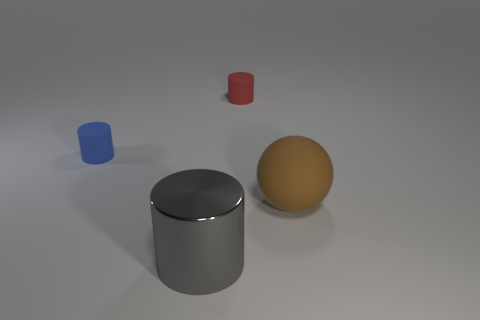Subtract all tiny rubber cylinders. How many cylinders are left? 1 Add 4 red things. How many objects exist? 8 Subtract all red cylinders. How many cylinders are left? 2 Subtract all spheres. How many objects are left? 3 Add 1 big matte things. How many big matte things are left? 2 Add 4 shiny cylinders. How many shiny cylinders exist? 5 Subtract 0 red balls. How many objects are left? 4 Subtract 1 cylinders. How many cylinders are left? 2 Subtract all gray cylinders. Subtract all yellow balls. How many cylinders are left? 2 Subtract all small brown rubber cylinders. Subtract all big gray cylinders. How many objects are left? 3 